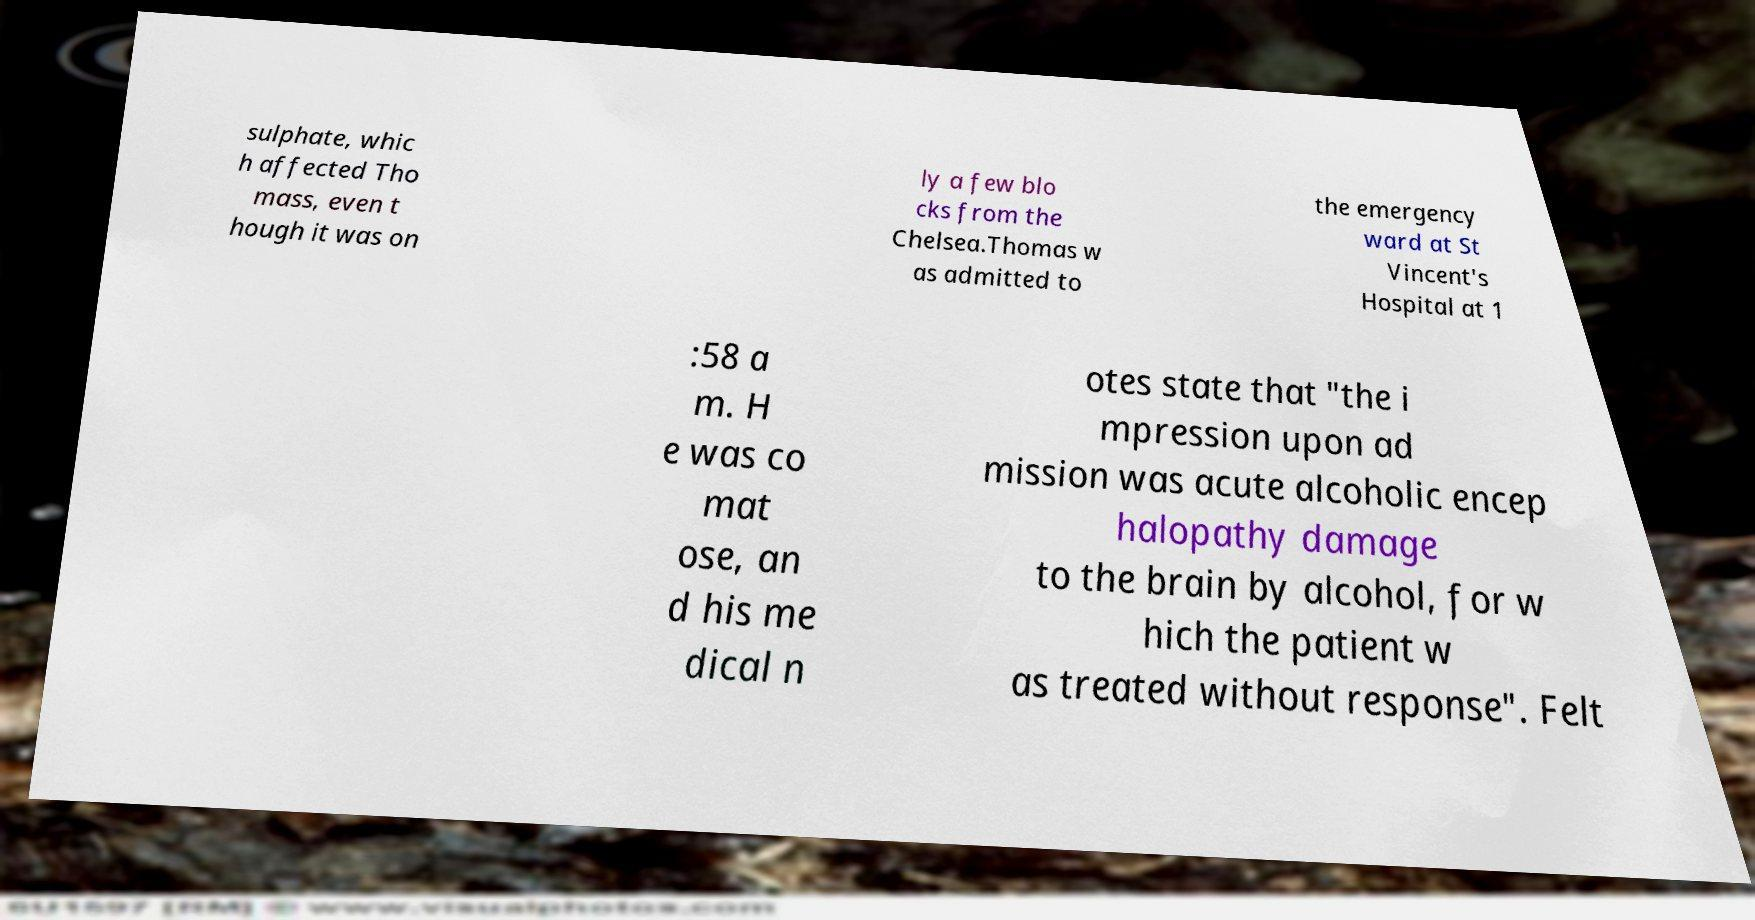I need the written content from this picture converted into text. Can you do that? sulphate, whic h affected Tho mass, even t hough it was on ly a few blo cks from the Chelsea.Thomas w as admitted to the emergency ward at St Vincent's Hospital at 1 :58 a m. H e was co mat ose, an d his me dical n otes state that "the i mpression upon ad mission was acute alcoholic encep halopathy damage to the brain by alcohol, for w hich the patient w as treated without response". Felt 